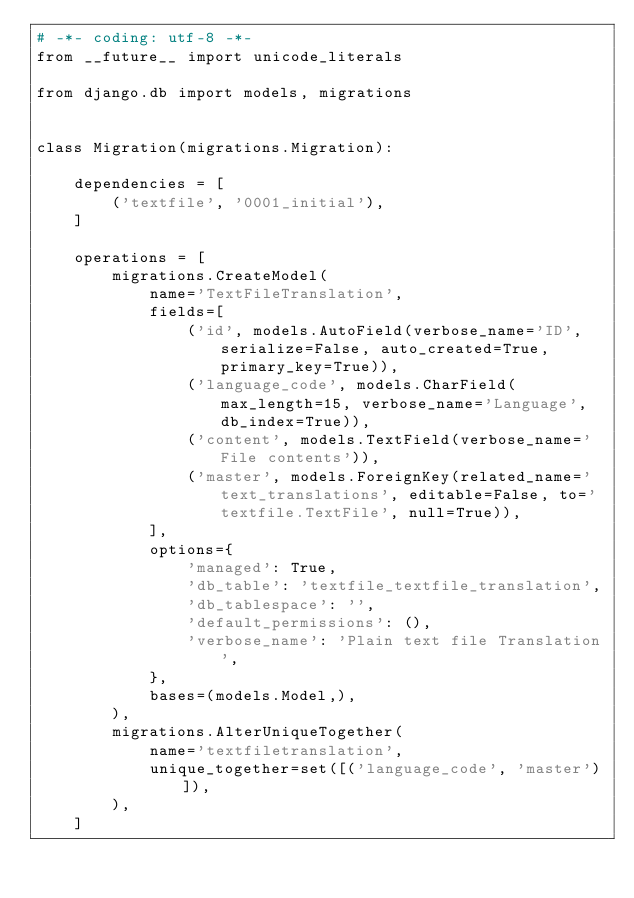Convert code to text. <code><loc_0><loc_0><loc_500><loc_500><_Python_># -*- coding: utf-8 -*-
from __future__ import unicode_literals

from django.db import models, migrations


class Migration(migrations.Migration):

    dependencies = [
        ('textfile', '0001_initial'),
    ]

    operations = [
        migrations.CreateModel(
            name='TextFileTranslation',
            fields=[
                ('id', models.AutoField(verbose_name='ID', serialize=False, auto_created=True, primary_key=True)),
                ('language_code', models.CharField(max_length=15, verbose_name='Language', db_index=True)),
                ('content', models.TextField(verbose_name='File contents')),
                ('master', models.ForeignKey(related_name='text_translations', editable=False, to='textfile.TextFile', null=True)),
            ],
            options={
                'managed': True,
                'db_table': 'textfile_textfile_translation',
                'db_tablespace': '',
                'default_permissions': (),
                'verbose_name': 'Plain text file Translation',
            },
            bases=(models.Model,),
        ),
        migrations.AlterUniqueTogether(
            name='textfiletranslation',
            unique_together=set([('language_code', 'master')]),
        ),
    ]
</code> 